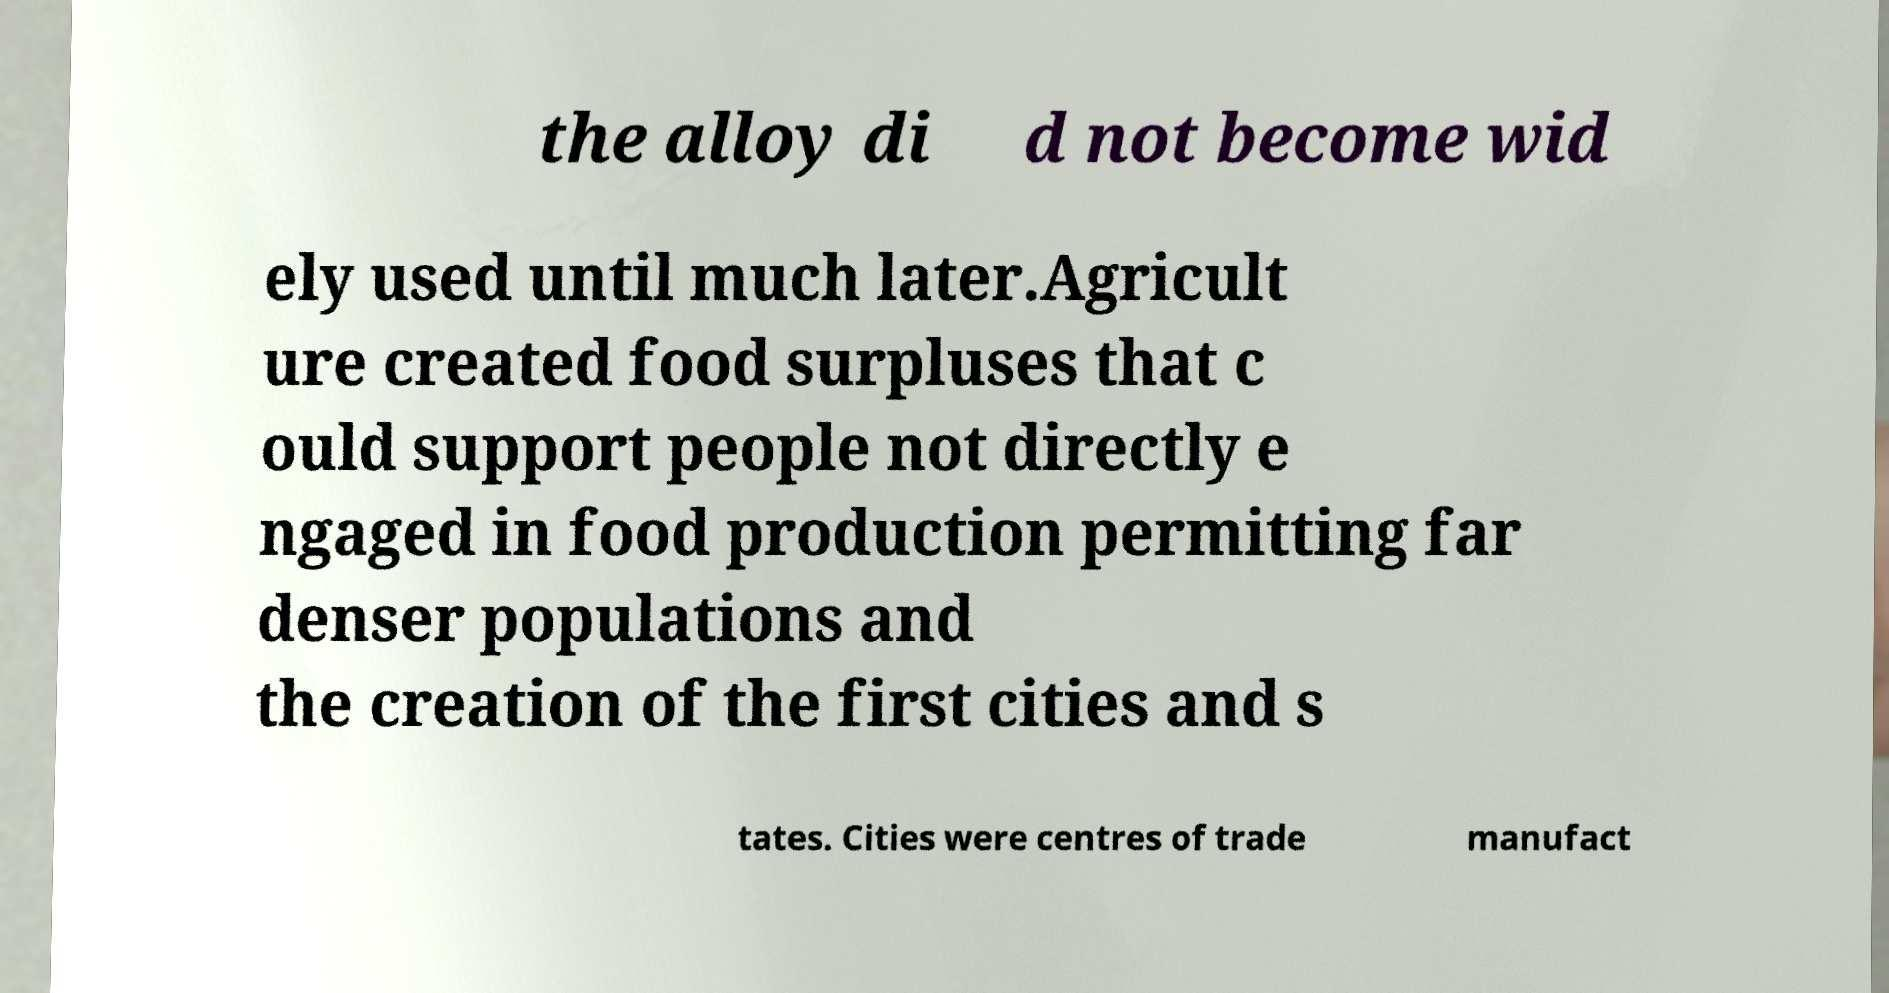Can you accurately transcribe the text from the provided image for me? the alloy di d not become wid ely used until much later.Agricult ure created food surpluses that c ould support people not directly e ngaged in food production permitting far denser populations and the creation of the first cities and s tates. Cities were centres of trade manufact 